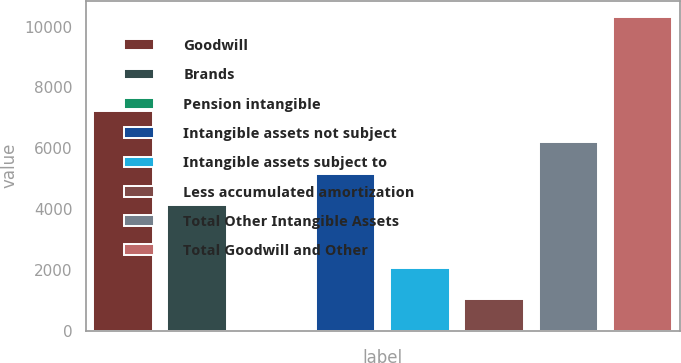Convert chart to OTSL. <chart><loc_0><loc_0><loc_500><loc_500><bar_chart><fcel>Goodwill<fcel>Brands<fcel>Pension intangible<fcel>Intangible assets not subject<fcel>Intangible assets subject to<fcel>Less accumulated amortization<fcel>Total Other Intangible Assets<fcel>Total Goodwill and Other<nl><fcel>7229.3<fcel>4133.6<fcel>6<fcel>5165.5<fcel>2069.8<fcel>1037.9<fcel>6197.4<fcel>10325<nl></chart> 